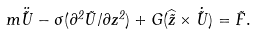<formula> <loc_0><loc_0><loc_500><loc_500>m \ddot { \vec { U } } - \sigma ( \partial ^ { 2 } \vec { U } / \partial z ^ { 2 } ) + G ( \widehat { \vec { z } } \times \dot { \vec { U } } ) = \vec { F } .</formula> 